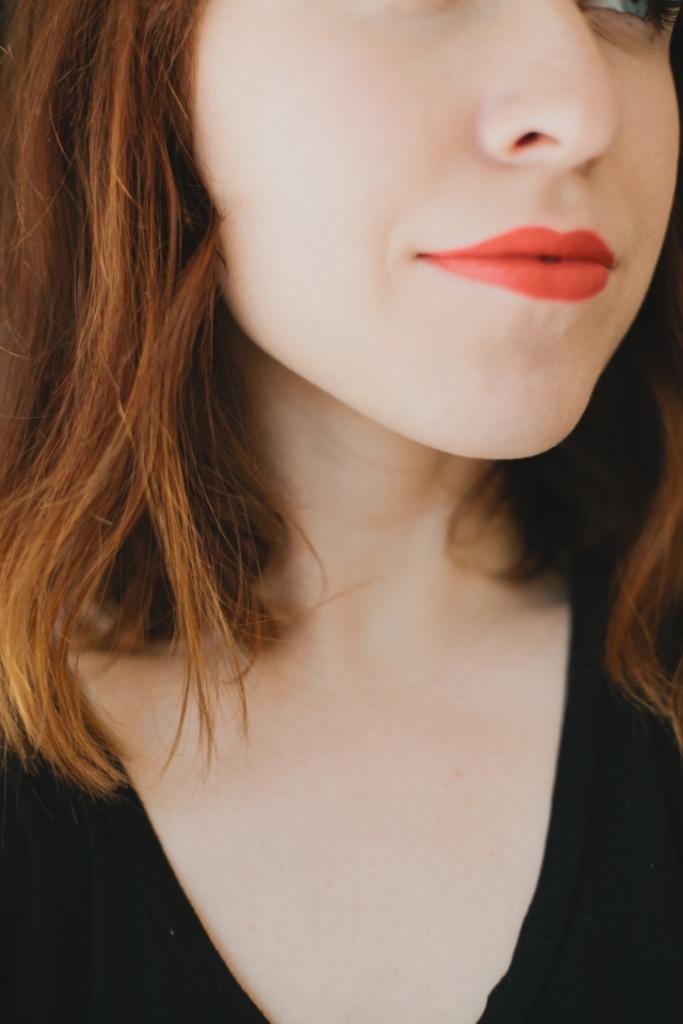In one or two sentences, can you explain what this image depicts? In this image we can able to see a girl who is wearing a black color dress, and applied a red color lipstick, and she has a brown color hair. 